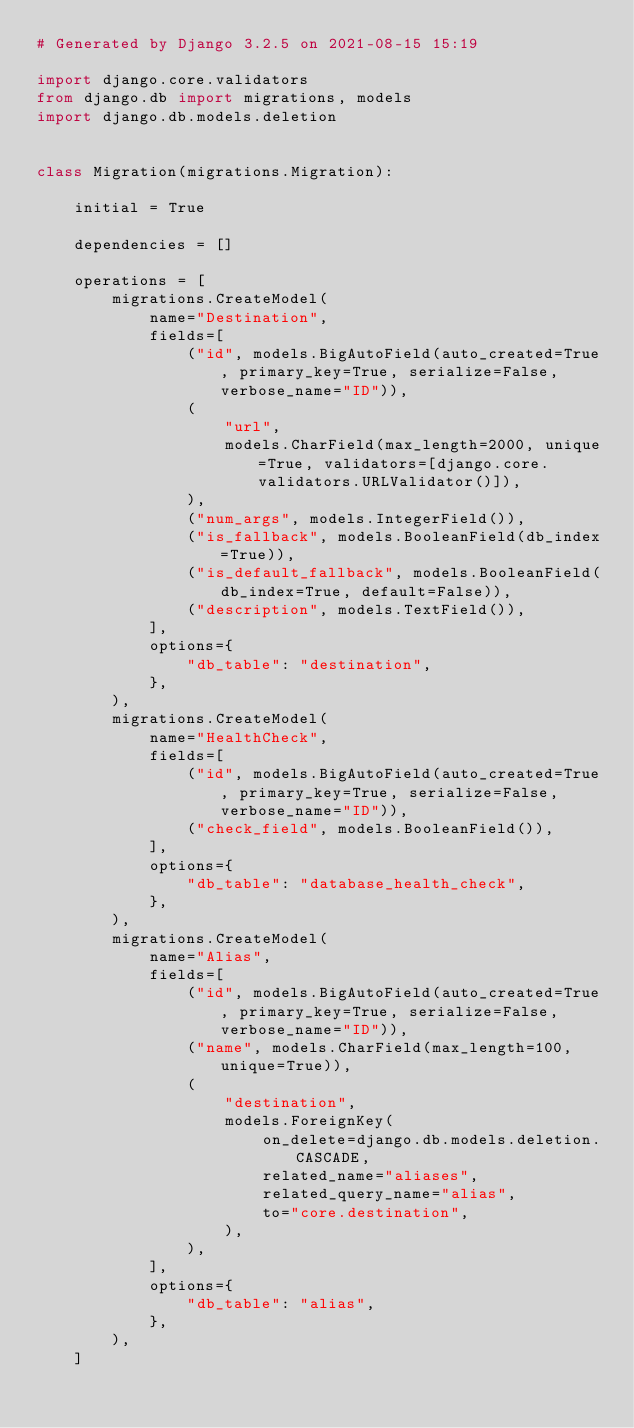Convert code to text. <code><loc_0><loc_0><loc_500><loc_500><_Python_># Generated by Django 3.2.5 on 2021-08-15 15:19

import django.core.validators
from django.db import migrations, models
import django.db.models.deletion


class Migration(migrations.Migration):

    initial = True

    dependencies = []

    operations = [
        migrations.CreateModel(
            name="Destination",
            fields=[
                ("id", models.BigAutoField(auto_created=True, primary_key=True, serialize=False, verbose_name="ID")),
                (
                    "url",
                    models.CharField(max_length=2000, unique=True, validators=[django.core.validators.URLValidator()]),
                ),
                ("num_args", models.IntegerField()),
                ("is_fallback", models.BooleanField(db_index=True)),
                ("is_default_fallback", models.BooleanField(db_index=True, default=False)),
                ("description", models.TextField()),
            ],
            options={
                "db_table": "destination",
            },
        ),
        migrations.CreateModel(
            name="HealthCheck",
            fields=[
                ("id", models.BigAutoField(auto_created=True, primary_key=True, serialize=False, verbose_name="ID")),
                ("check_field", models.BooleanField()),
            ],
            options={
                "db_table": "database_health_check",
            },
        ),
        migrations.CreateModel(
            name="Alias",
            fields=[
                ("id", models.BigAutoField(auto_created=True, primary_key=True, serialize=False, verbose_name="ID")),
                ("name", models.CharField(max_length=100, unique=True)),
                (
                    "destination",
                    models.ForeignKey(
                        on_delete=django.db.models.deletion.CASCADE,
                        related_name="aliases",
                        related_query_name="alias",
                        to="core.destination",
                    ),
                ),
            ],
            options={
                "db_table": "alias",
            },
        ),
    ]
</code> 